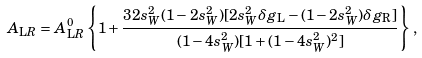Convert formula to latex. <formula><loc_0><loc_0><loc_500><loc_500>A _ { \mathrm L R } = A _ { \mathrm L R } ^ { 0 } \left \{ 1 + \frac { 3 2 s _ { W } ^ { 2 } ( 1 - 2 s _ { W } ^ { 2 } ) [ 2 s _ { W } ^ { 2 } \delta g _ { \mathrm L } - ( 1 - 2 s _ { W } ^ { 2 } ) \delta g _ { \mathrm R } ] } { ( 1 - 4 s _ { W } ^ { 2 } ) [ 1 + ( 1 - 4 s _ { W } ^ { 2 } ) ^ { 2 } ] } \right \} \, ,</formula> 